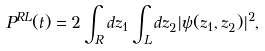Convert formula to latex. <formula><loc_0><loc_0><loc_500><loc_500>P ^ { R L } ( t ) = 2 \int _ { R } d z _ { 1 } \int _ { L } d z _ { 2 } | \psi ( z _ { 1 } , z _ { 2 } ) | ^ { 2 } ,</formula> 